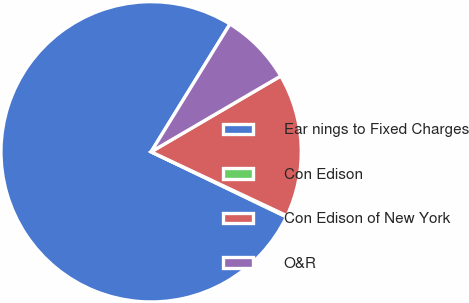Convert chart to OTSL. <chart><loc_0><loc_0><loc_500><loc_500><pie_chart><fcel>Ear nings to Fixed Charges<fcel>Con Edison<fcel>Con Edison of New York<fcel>O&R<nl><fcel>76.66%<fcel>0.13%<fcel>15.43%<fcel>7.78%<nl></chart> 